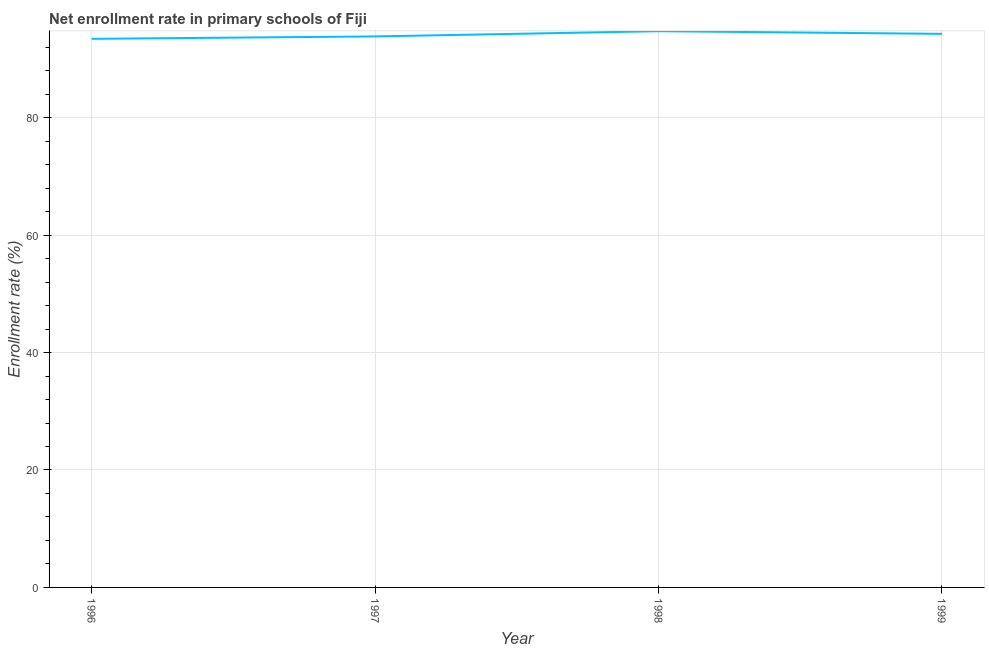What is the net enrollment rate in primary schools in 1997?
Offer a terse response. 93.83. Across all years, what is the maximum net enrollment rate in primary schools?
Your response must be concise. 94.72. Across all years, what is the minimum net enrollment rate in primary schools?
Ensure brevity in your answer.  93.43. In which year was the net enrollment rate in primary schools maximum?
Your answer should be compact. 1998. In which year was the net enrollment rate in primary schools minimum?
Make the answer very short. 1996. What is the sum of the net enrollment rate in primary schools?
Your response must be concise. 376.26. What is the difference between the net enrollment rate in primary schools in 1996 and 1998?
Give a very brief answer. -1.3. What is the average net enrollment rate in primary schools per year?
Offer a terse response. 94.06. What is the median net enrollment rate in primary schools?
Offer a very short reply. 94.05. What is the ratio of the net enrollment rate in primary schools in 1996 to that in 1999?
Provide a short and direct response. 0.99. Is the difference between the net enrollment rate in primary schools in 1997 and 1999 greater than the difference between any two years?
Ensure brevity in your answer.  No. What is the difference between the highest and the second highest net enrollment rate in primary schools?
Your answer should be compact. 0.45. What is the difference between the highest and the lowest net enrollment rate in primary schools?
Make the answer very short. 1.3. In how many years, is the net enrollment rate in primary schools greater than the average net enrollment rate in primary schools taken over all years?
Your answer should be compact. 2. How many lines are there?
Offer a terse response. 1. Does the graph contain any zero values?
Your response must be concise. No. Does the graph contain grids?
Your answer should be very brief. Yes. What is the title of the graph?
Ensure brevity in your answer.  Net enrollment rate in primary schools of Fiji. What is the label or title of the X-axis?
Keep it short and to the point. Year. What is the label or title of the Y-axis?
Your response must be concise. Enrollment rate (%). What is the Enrollment rate (%) of 1996?
Your response must be concise. 93.43. What is the Enrollment rate (%) of 1997?
Give a very brief answer. 93.83. What is the Enrollment rate (%) in 1998?
Provide a short and direct response. 94.72. What is the Enrollment rate (%) of 1999?
Your answer should be very brief. 94.27. What is the difference between the Enrollment rate (%) in 1996 and 1997?
Offer a terse response. -0.41. What is the difference between the Enrollment rate (%) in 1996 and 1998?
Give a very brief answer. -1.3. What is the difference between the Enrollment rate (%) in 1996 and 1999?
Provide a short and direct response. -0.85. What is the difference between the Enrollment rate (%) in 1997 and 1998?
Ensure brevity in your answer.  -0.89. What is the difference between the Enrollment rate (%) in 1997 and 1999?
Offer a terse response. -0.44. What is the difference between the Enrollment rate (%) in 1998 and 1999?
Provide a succinct answer. 0.45. What is the ratio of the Enrollment rate (%) in 1996 to that in 1997?
Your response must be concise. 1. What is the ratio of the Enrollment rate (%) in 1997 to that in 1998?
Your answer should be compact. 0.99. What is the ratio of the Enrollment rate (%) in 1997 to that in 1999?
Your answer should be very brief. 0.99. 